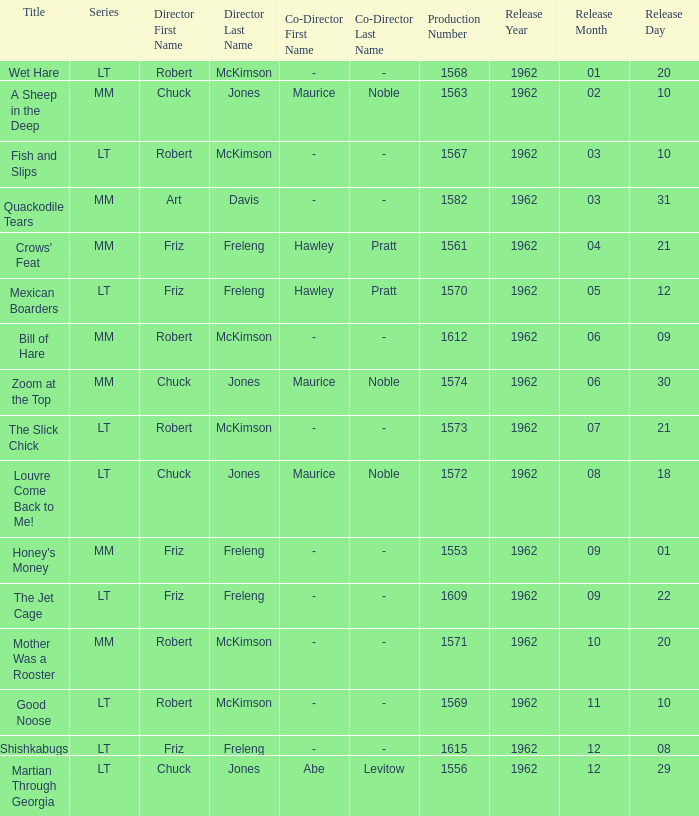What is Crows' Feat's production number? 1561.0. 